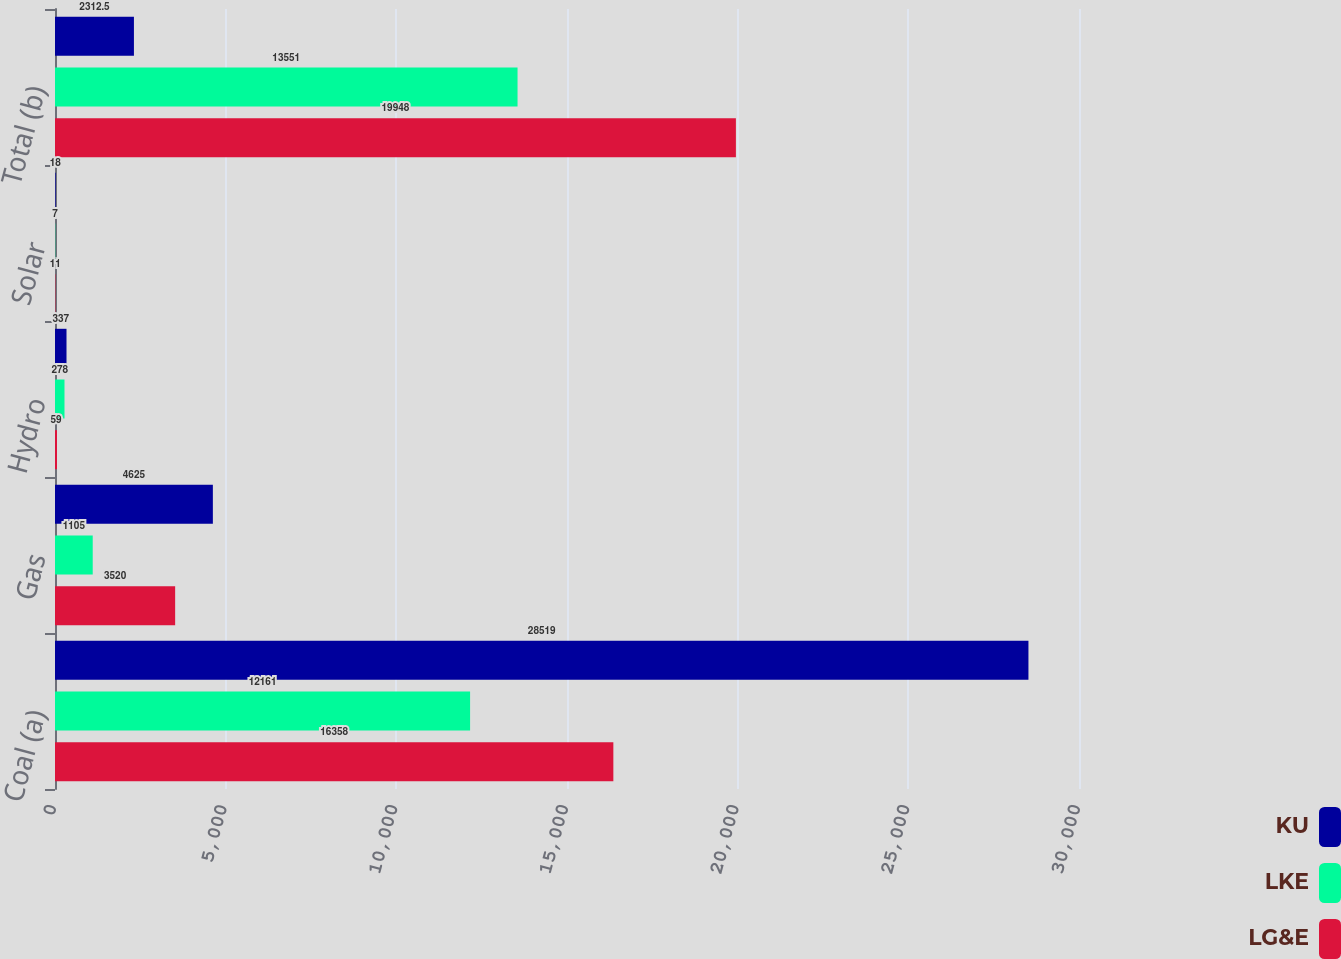Convert chart. <chart><loc_0><loc_0><loc_500><loc_500><stacked_bar_chart><ecel><fcel>Coal (a)<fcel>Gas<fcel>Hydro<fcel>Solar<fcel>Total (b)<nl><fcel>KU<fcel>28519<fcel>4625<fcel>337<fcel>18<fcel>2312.5<nl><fcel>LKE<fcel>12161<fcel>1105<fcel>278<fcel>7<fcel>13551<nl><fcel>LG&E<fcel>16358<fcel>3520<fcel>59<fcel>11<fcel>19948<nl></chart> 